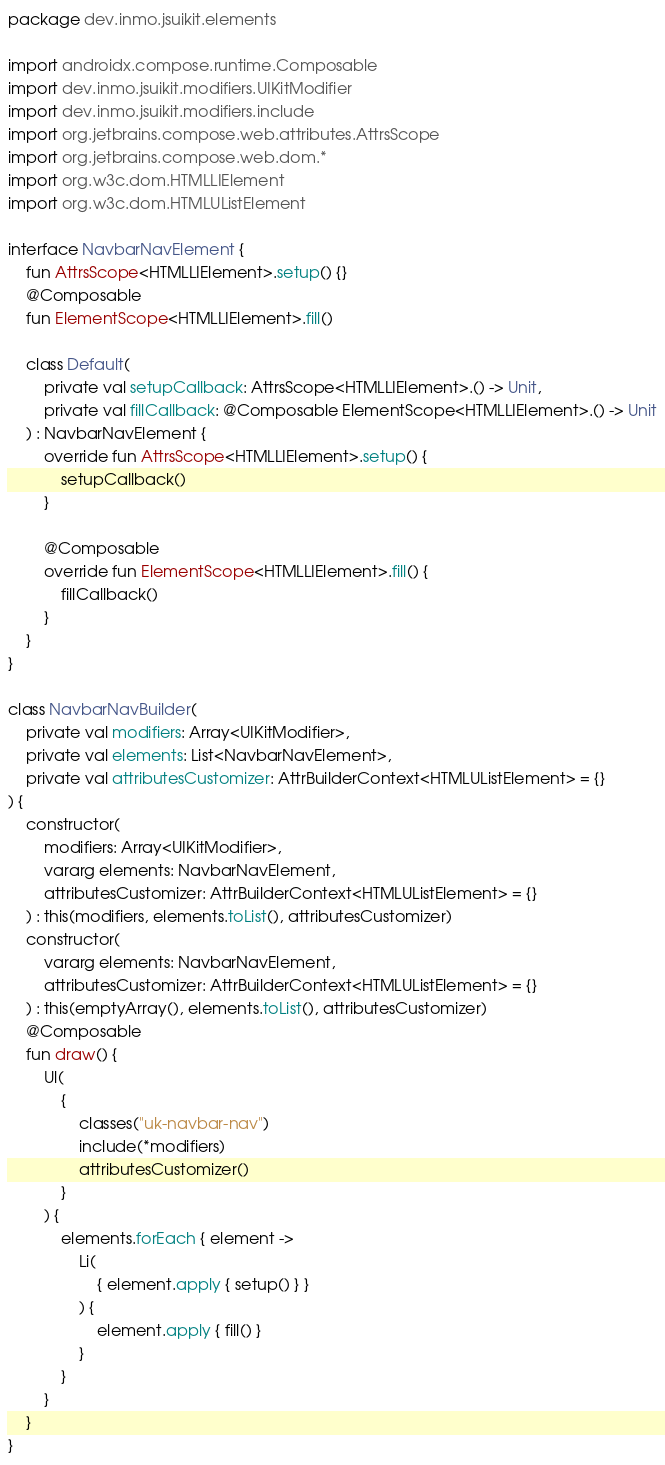<code> <loc_0><loc_0><loc_500><loc_500><_Kotlin_>package dev.inmo.jsuikit.elements

import androidx.compose.runtime.Composable
import dev.inmo.jsuikit.modifiers.UIKitModifier
import dev.inmo.jsuikit.modifiers.include
import org.jetbrains.compose.web.attributes.AttrsScope
import org.jetbrains.compose.web.dom.*
import org.w3c.dom.HTMLLIElement
import org.w3c.dom.HTMLUListElement

interface NavbarNavElement {
    fun AttrsScope<HTMLLIElement>.setup() {}
    @Composable
    fun ElementScope<HTMLLIElement>.fill()

    class Default(
        private val setupCallback: AttrsScope<HTMLLIElement>.() -> Unit,
        private val fillCallback: @Composable ElementScope<HTMLLIElement>.() -> Unit
    ) : NavbarNavElement {
        override fun AttrsScope<HTMLLIElement>.setup() {
            setupCallback()
        }

        @Composable
        override fun ElementScope<HTMLLIElement>.fill() {
            fillCallback()
        }
    }
}

class NavbarNavBuilder(
    private val modifiers: Array<UIKitModifier>,
    private val elements: List<NavbarNavElement>,
    private val attributesCustomizer: AttrBuilderContext<HTMLUListElement> = {}
) {
    constructor(
        modifiers: Array<UIKitModifier>,
        vararg elements: NavbarNavElement,
        attributesCustomizer: AttrBuilderContext<HTMLUListElement> = {}
    ) : this(modifiers, elements.toList(), attributesCustomizer)
    constructor(
        vararg elements: NavbarNavElement,
        attributesCustomizer: AttrBuilderContext<HTMLUListElement> = {}
    ) : this(emptyArray(), elements.toList(), attributesCustomizer)
    @Composable
    fun draw() {
        Ul(
            {
                classes("uk-navbar-nav")
                include(*modifiers)
                attributesCustomizer()
            }
        ) {
            elements.forEach { element ->
                Li(
                    { element.apply { setup() } }
                ) {
                    element.apply { fill() }
                }
            }
        }
    }
}
</code> 